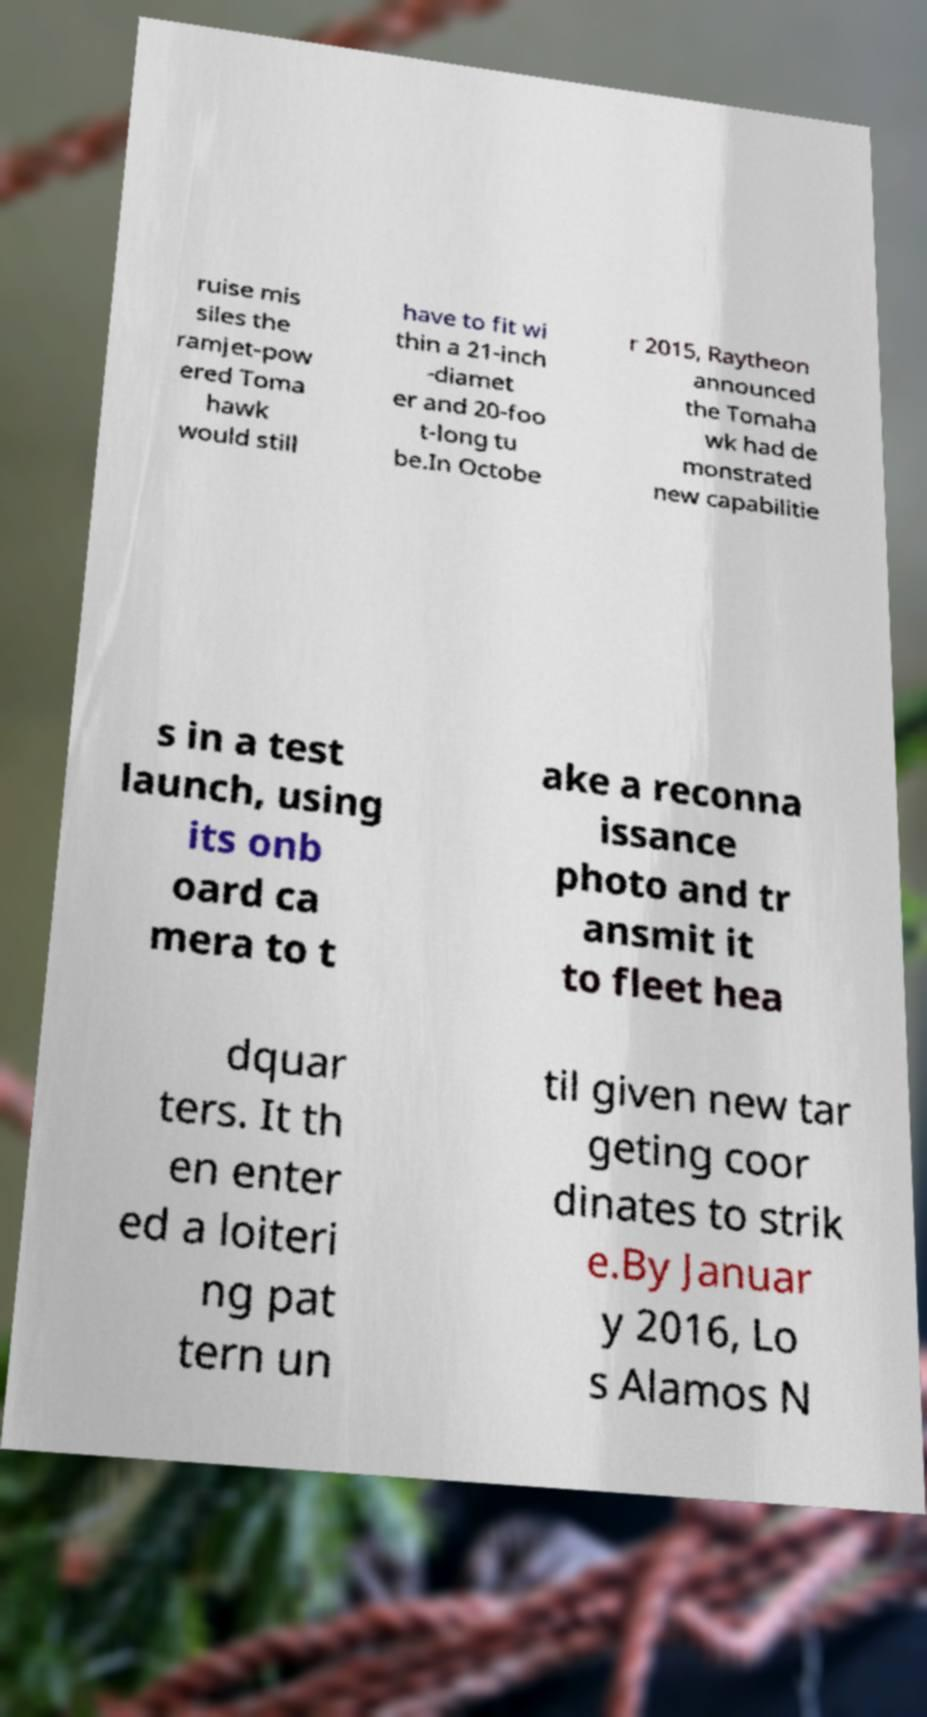Please read and relay the text visible in this image. What does it say? ruise mis siles the ramjet-pow ered Toma hawk would still have to fit wi thin a 21-inch -diamet er and 20-foo t-long tu be.In Octobe r 2015, Raytheon announced the Tomaha wk had de monstrated new capabilitie s in a test launch, using its onb oard ca mera to t ake a reconna issance photo and tr ansmit it to fleet hea dquar ters. It th en enter ed a loiteri ng pat tern un til given new tar geting coor dinates to strik e.By Januar y 2016, Lo s Alamos N 